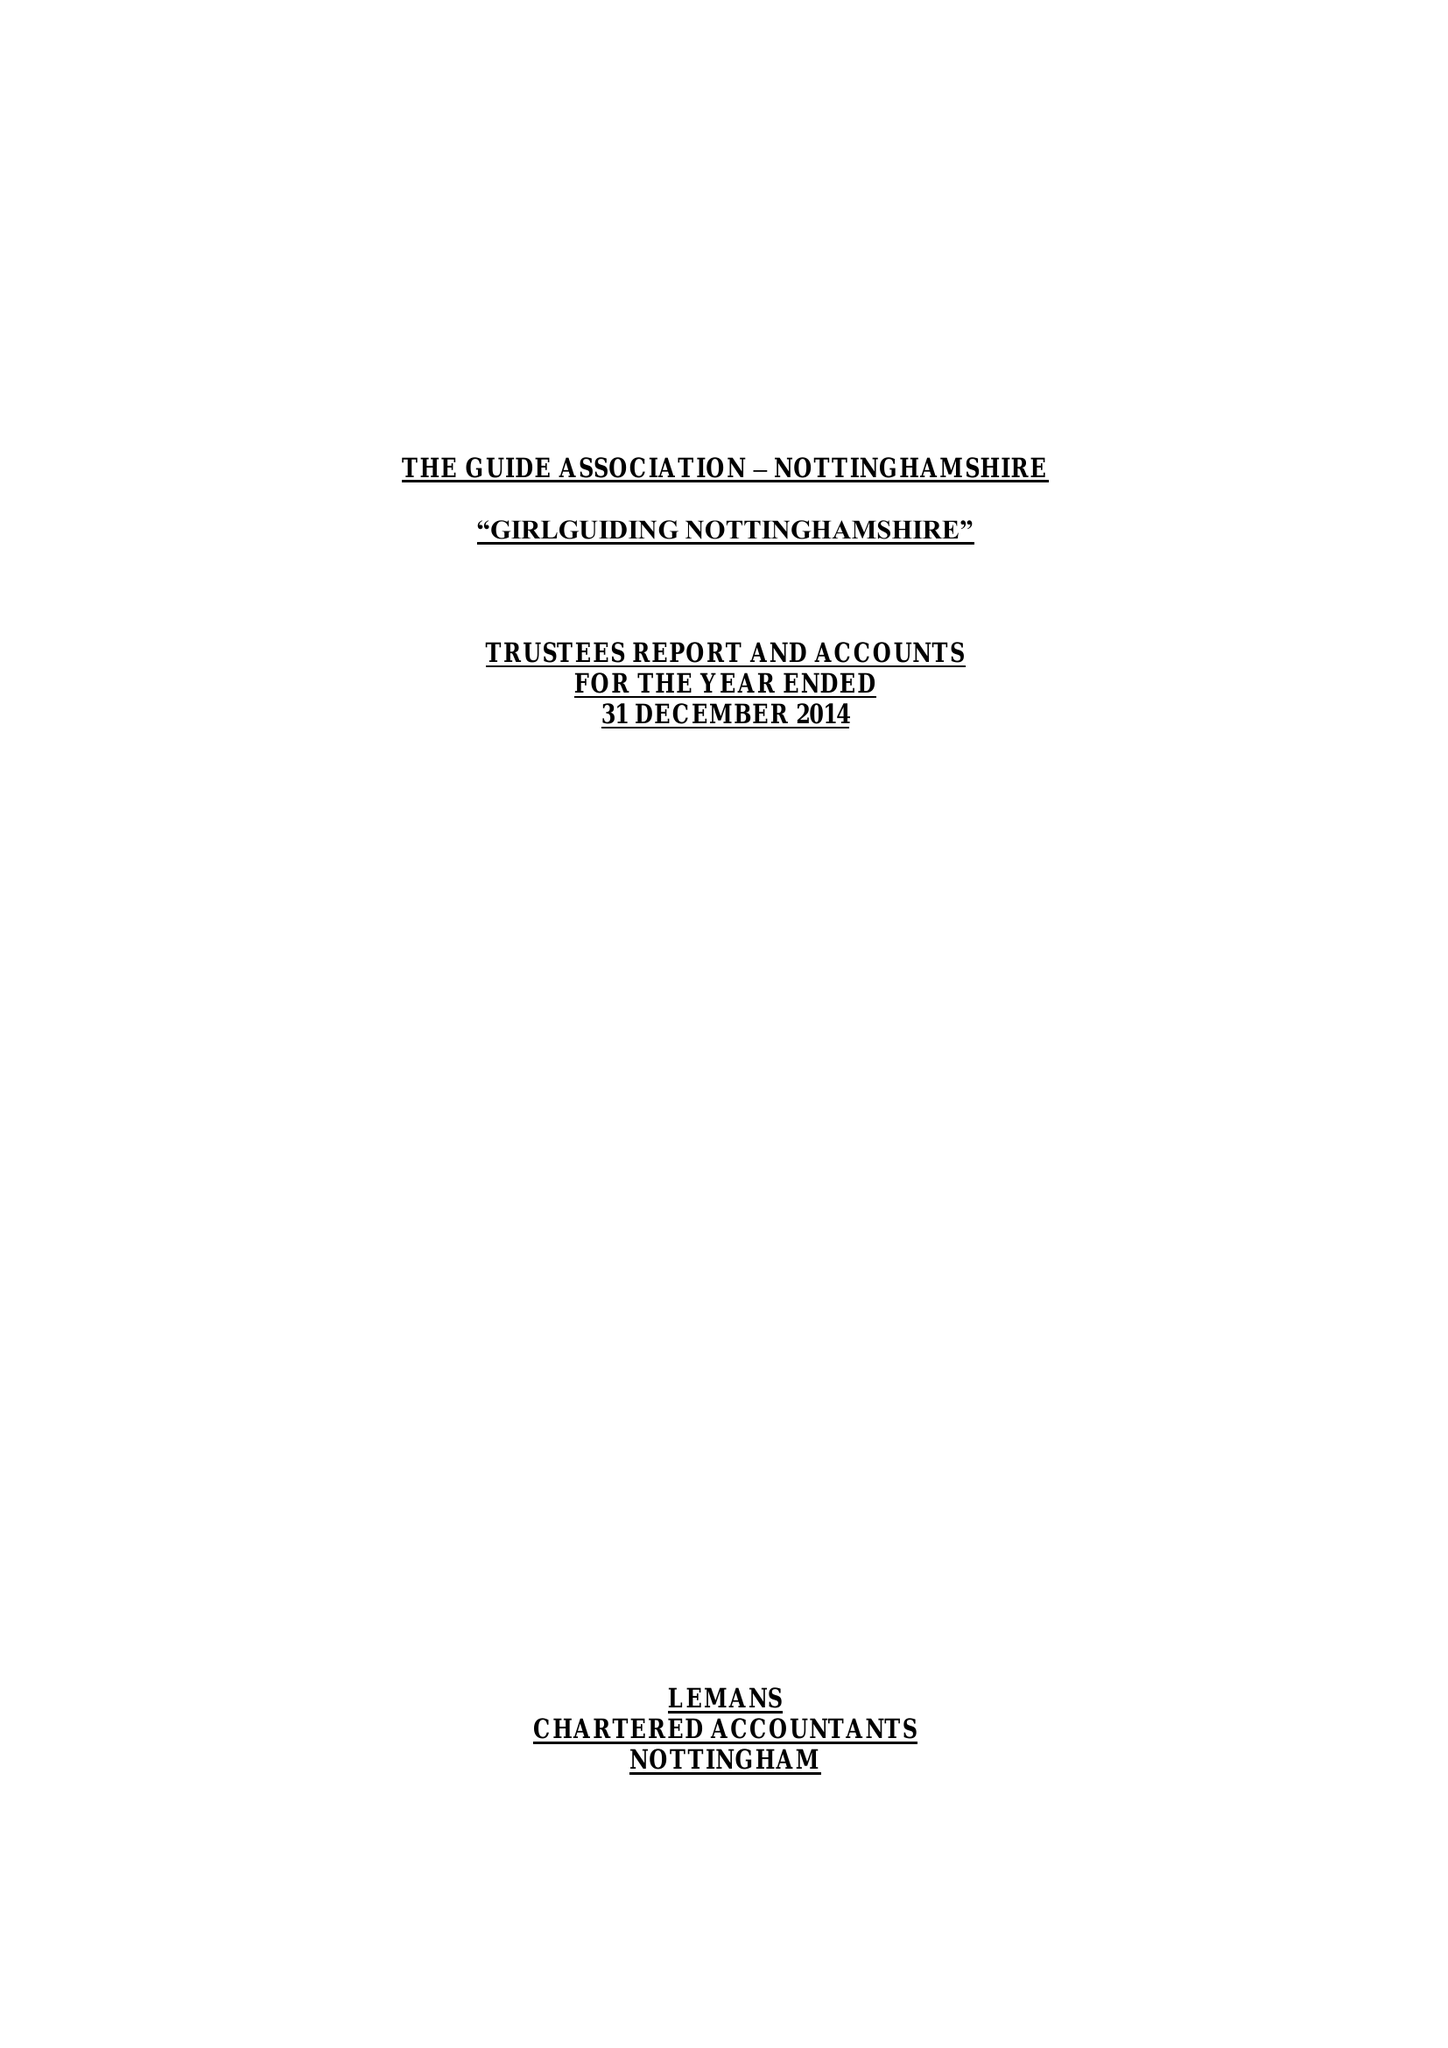What is the value for the report_date?
Answer the question using a single word or phrase. 2014-12-31 